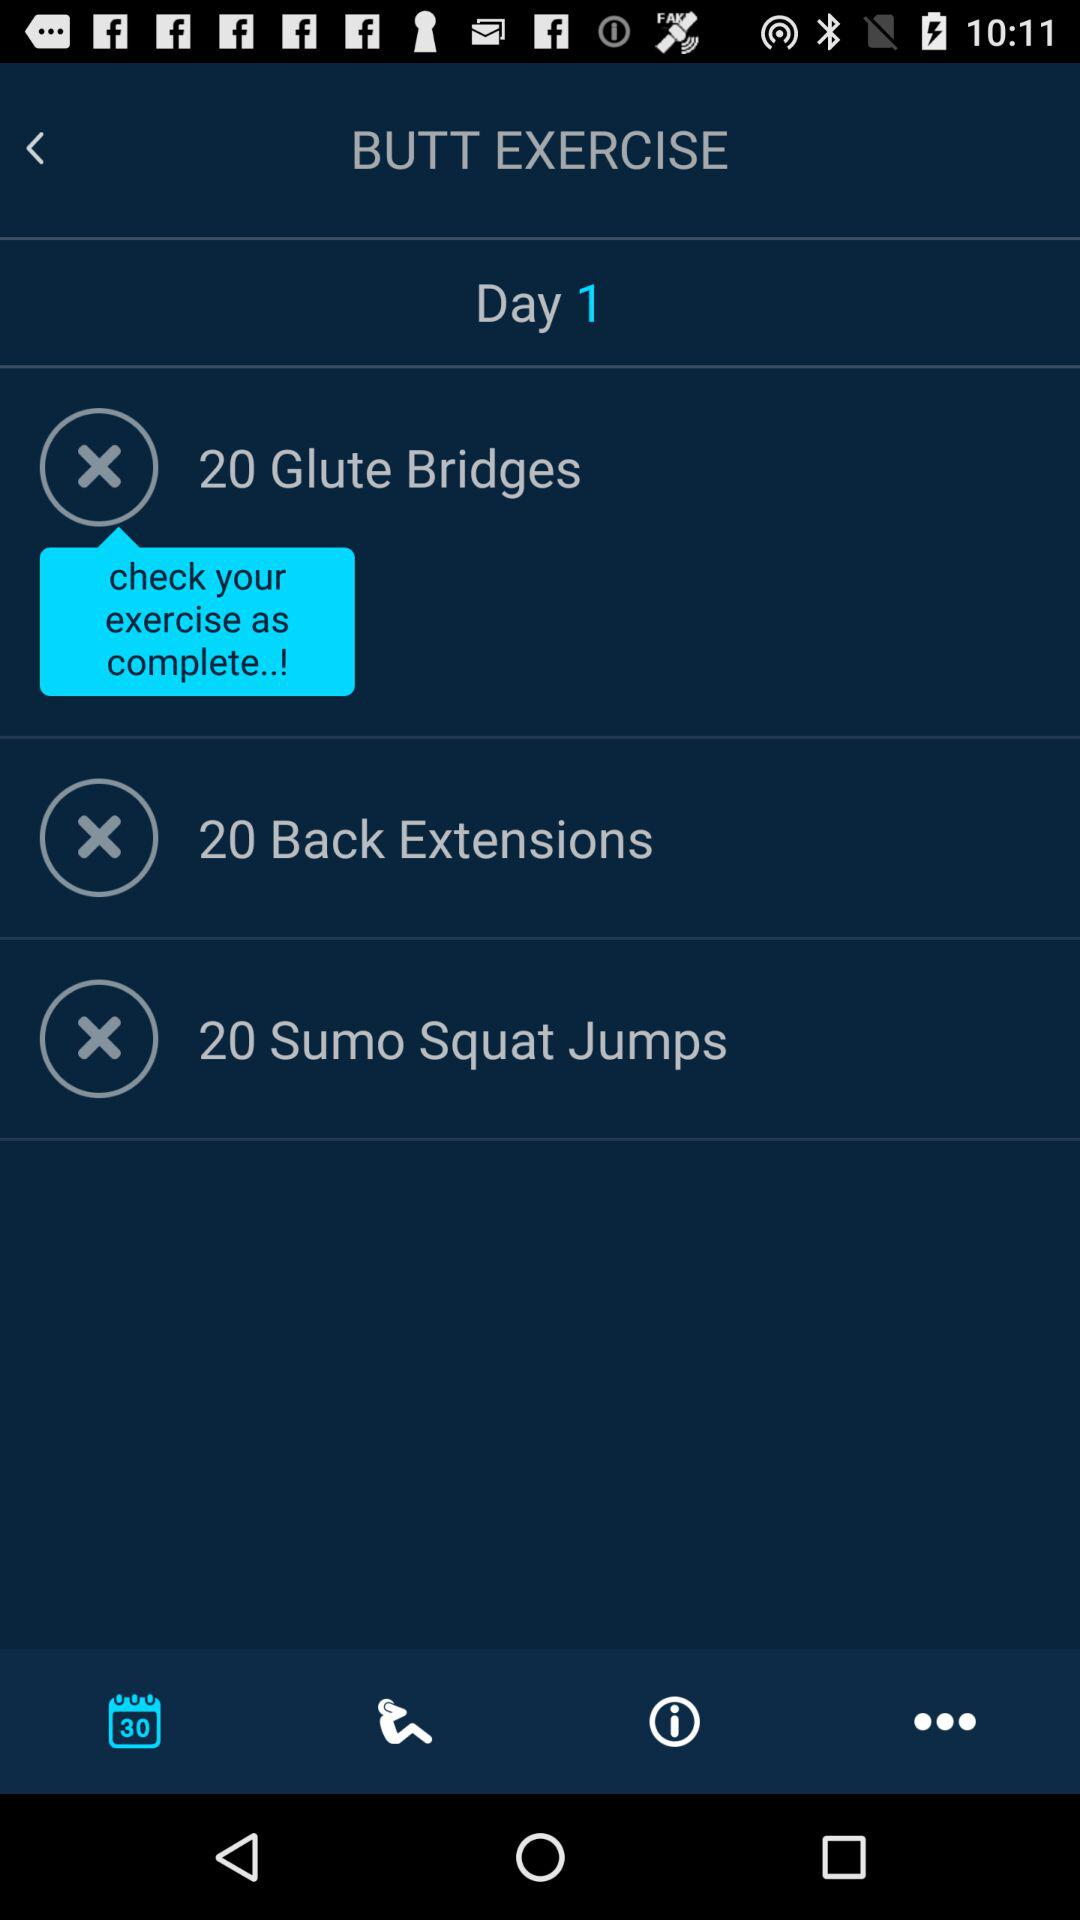What are the butt exercises? The butt exercises are glute bridges, back extensions and sumo squat jumps. 